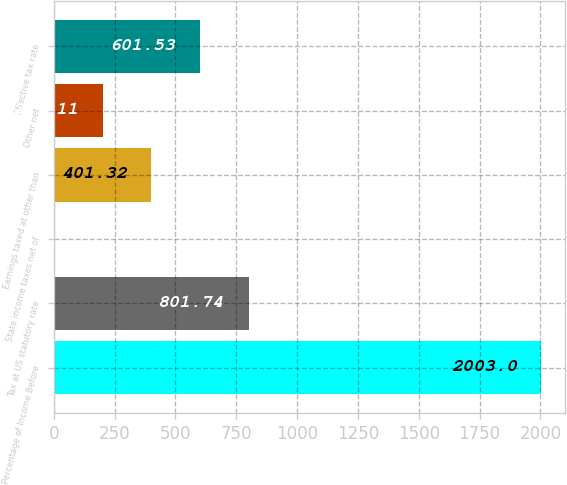Convert chart to OTSL. <chart><loc_0><loc_0><loc_500><loc_500><bar_chart><fcel>Percentage of Income Before<fcel>Tax at US statutory rate<fcel>State income taxes net of<fcel>Earnings taxed at other than<fcel>Other net<fcel>Effective tax rate<nl><fcel>2003<fcel>801.74<fcel>0.9<fcel>401.32<fcel>201.11<fcel>601.53<nl></chart> 